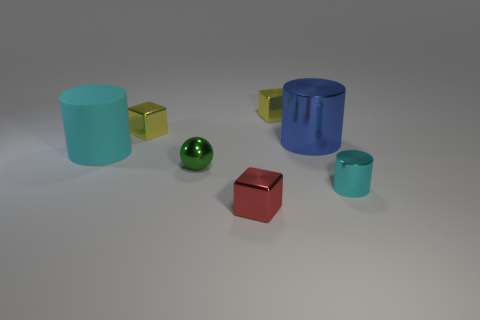What material is the ball?
Your answer should be very brief. Metal. There is a blue object that is the same material as the small cyan object; what shape is it?
Offer a terse response. Cylinder. How big is the cyan cylinder that is on the left side of the green shiny sphere that is behind the red block?
Your answer should be very brief. Large. There is a block that is in front of the blue metallic object; what is its color?
Provide a short and direct response. Red. Are there any other tiny things of the same shape as the red shiny thing?
Provide a succinct answer. Yes. Is the number of big blue metallic cylinders that are behind the green metal thing less than the number of small metal objects that are behind the matte object?
Give a very brief answer. Yes. The small metal cylinder is what color?
Give a very brief answer. Cyan. There is a cyan object that is in front of the green metallic thing; are there any tiny red blocks that are in front of it?
Your response must be concise. Yes. How many gray rubber things have the same size as the blue cylinder?
Offer a very short reply. 0. What number of small green balls are on the right side of the red metallic object that is on the right side of the cyan thing left of the tiny cylinder?
Your response must be concise. 0. 